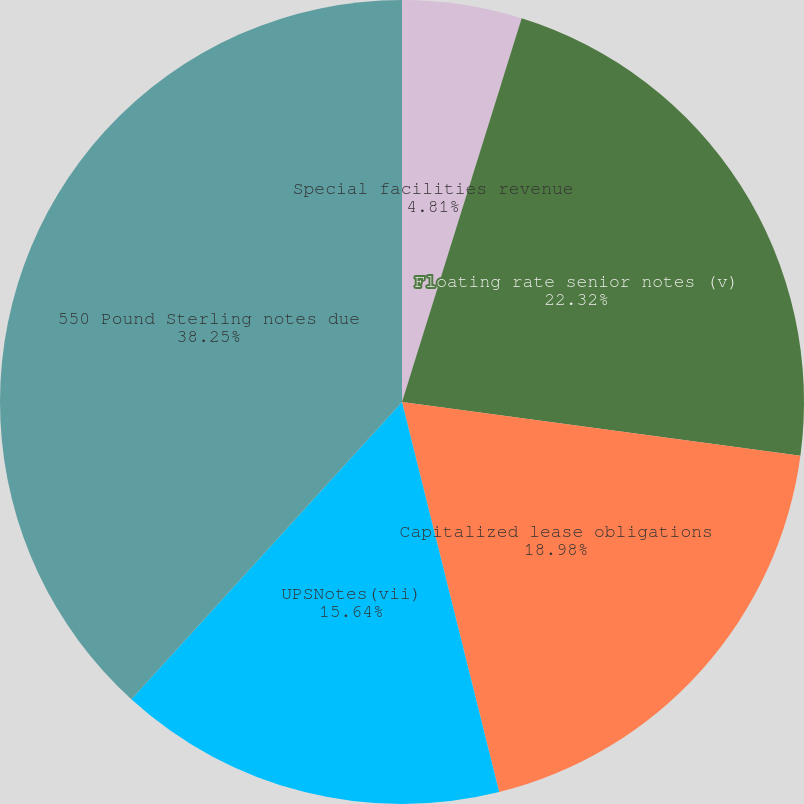Convert chart to OTSL. <chart><loc_0><loc_0><loc_500><loc_500><pie_chart><fcel>Special facilities revenue<fcel>Floating rate senior notes (v)<fcel>Capitalized lease obligations<fcel>UPSNotes(vii)<fcel>550 Pound Sterling notes due<nl><fcel>4.81%<fcel>22.32%<fcel>18.98%<fcel>15.64%<fcel>38.24%<nl></chart> 